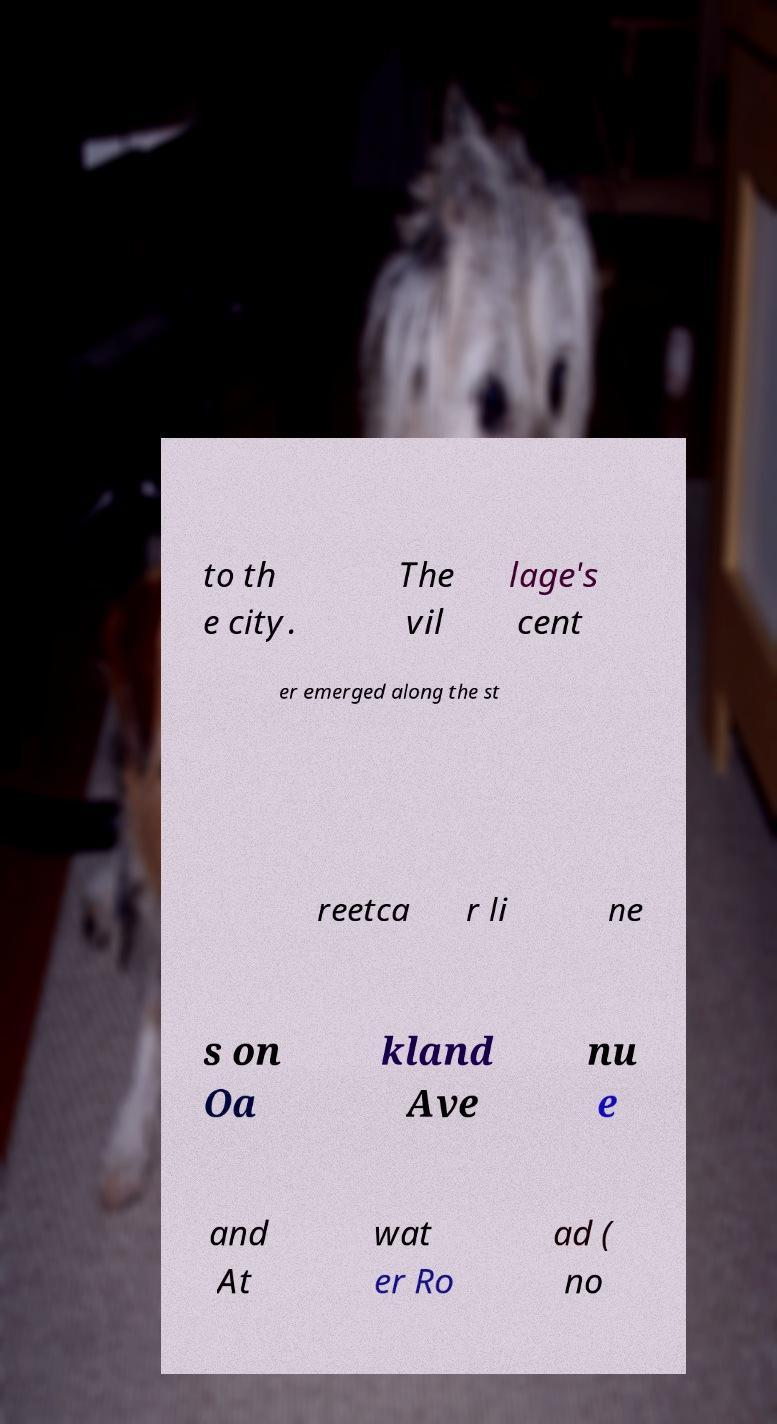There's text embedded in this image that I need extracted. Can you transcribe it verbatim? to th e city. The vil lage's cent er emerged along the st reetca r li ne s on Oa kland Ave nu e and At wat er Ro ad ( no 